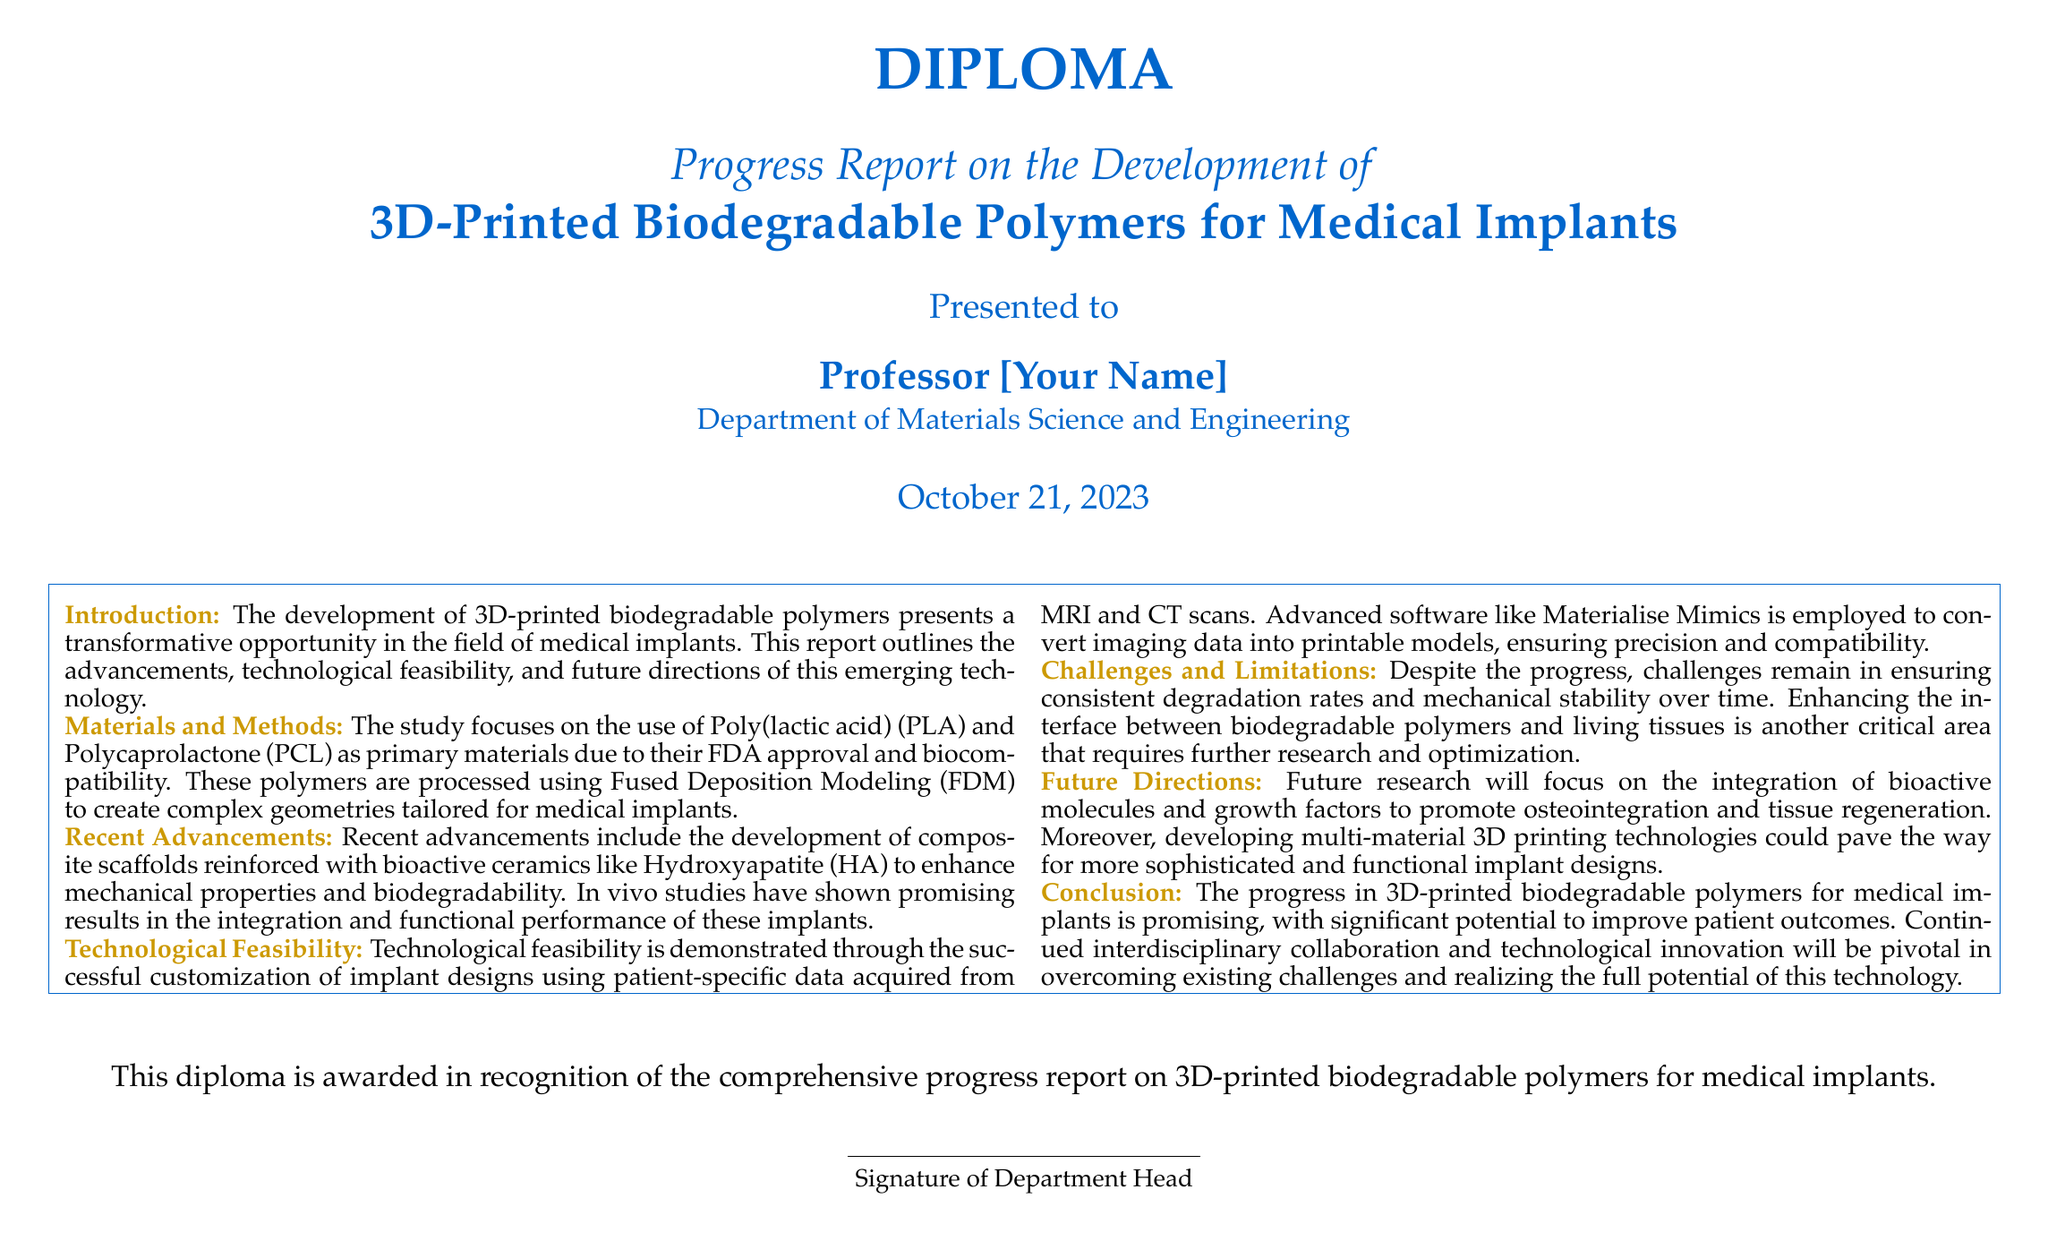what is the title of the diploma? The title is stated prominently at the top of the document as "Progress Report on the Development of 3D-Printed Biodegradable Polymers for Medical Implants."
Answer: Progress Report on the Development of 3D-Printed Biodegradable Polymers for Medical Implants who is the diploma presented to? The document specifies the recipient as "Professor [Your Name]."
Answer: Professor [Your Name] what materials are primarily discussed in this report? The report highlights the use of Poly(lactic acid) (PLA) and Polycaprolactone (PCL) as primary materials.
Answer: Poly(lactic acid) (PLA) and Polycaprolactone (PCL) what technology is used for printing the polymers? The method employed for processing the polymers is identified as Fused Deposition Modeling (FDM).
Answer: Fused Deposition Modeling (FDM) what is one of the challenges mentioned? The report lists consistent degradation rates and mechanical stability over time as a challenge.
Answer: consistent degradation rates how is technological feasibility demonstrated in the report? The document mentions the successful customization of implant designs using patient-specific data acquired from MRI and CT scans.
Answer: customization of implant designs what does the future research aim to integrate? The future directions focus on the integration of bioactive molecules and growth factors.
Answer: bioactive molecules and growth factors when was the diploma awarded? The awarded date is specified as October 21, 2023.
Answer: October 21, 2023 